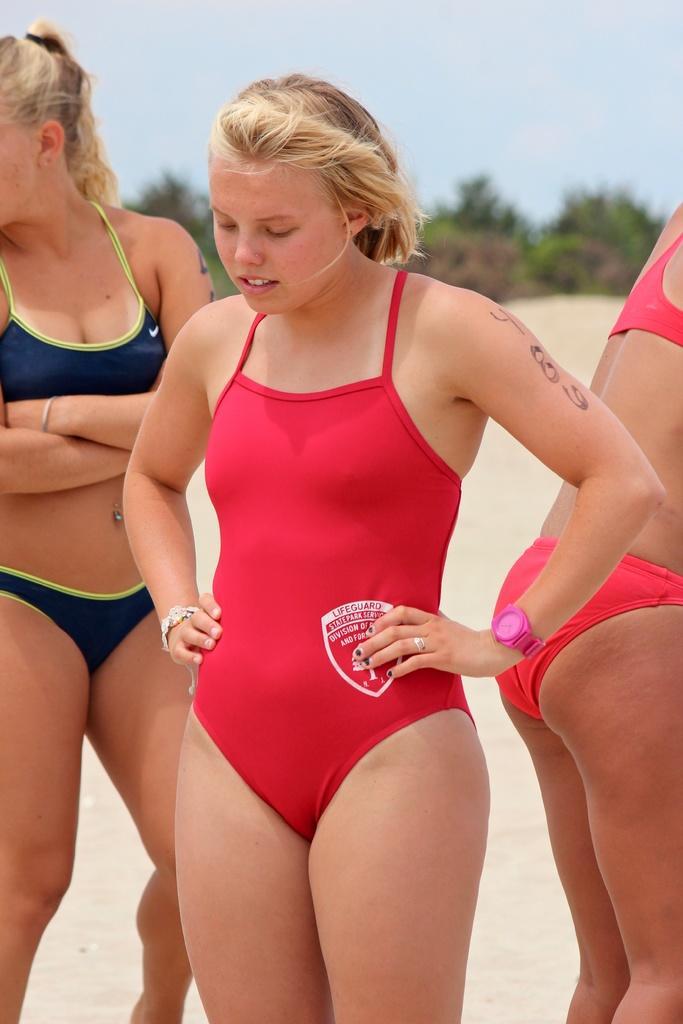Describe this image in one or two sentences. In this picture I can see 3 women standing in front and I see that they're wearing swimming suits. In the background I can see the trees and the sky and I see that it is blurred in the background. 